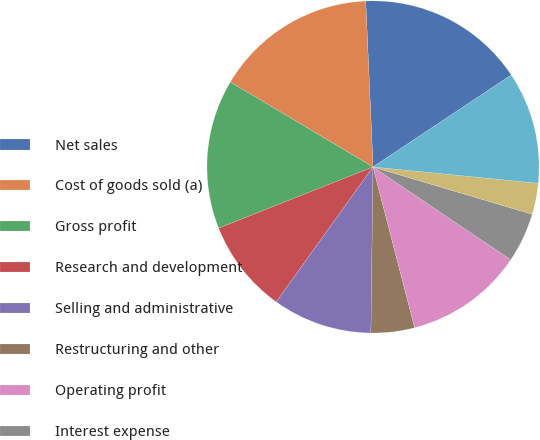<chart> <loc_0><loc_0><loc_500><loc_500><pie_chart><fcel>Net sales<fcel>Cost of goods sold (a)<fcel>Gross profit<fcel>Research and development<fcel>Selling and administrative<fcel>Restructuring and other<fcel>Operating profit<fcel>Interest expense<fcel>Other (income) expense net (d)<fcel>Income before taxes<nl><fcel>16.36%<fcel>15.76%<fcel>14.55%<fcel>9.09%<fcel>9.7%<fcel>4.24%<fcel>11.52%<fcel>4.85%<fcel>3.03%<fcel>10.91%<nl></chart> 